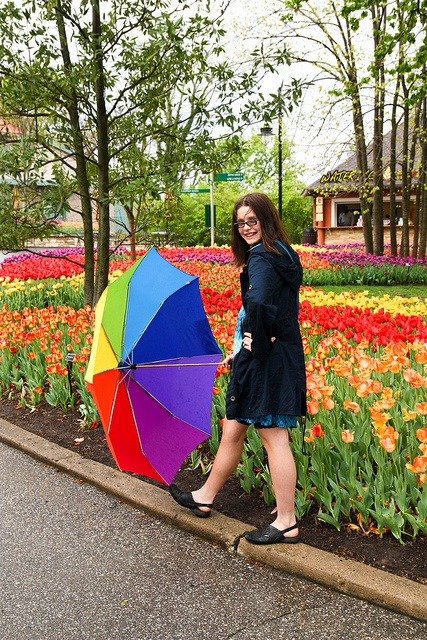Describe the objects in this image and their specific colors. I can see umbrella in white, darkblue, red, lightblue, and purple tones and people in white, black, tan, salmon, and maroon tones in this image. 